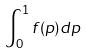<formula> <loc_0><loc_0><loc_500><loc_500>\int _ { 0 } ^ { 1 } f ( p ) d p</formula> 